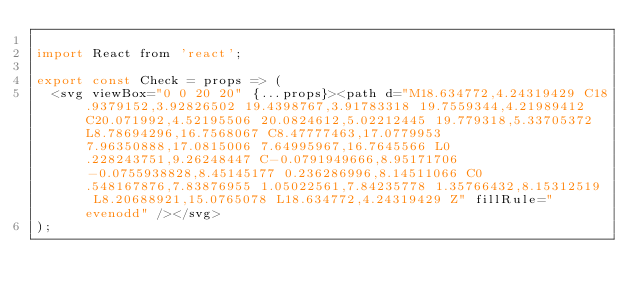<code> <loc_0><loc_0><loc_500><loc_500><_JavaScript_>
import React from 'react';

export const Check = props => (
  <svg viewBox="0 0 20 20" {...props}><path d="M18.634772,4.24319429 C18.9379152,3.92826502 19.4398767,3.91783318 19.7559344,4.21989412 C20.071992,4.52195506 20.0824612,5.02212445 19.779318,5.33705372 L8.78694296,16.7568067 C8.47777463,17.0779953 7.96350888,17.0815006 7.64995967,16.7645566 L0.228243751,9.26248447 C-0.0791949666,8.95171706 -0.0755938828,8.45145177 0.236286996,8.14511066 C0.548167876,7.83876955 1.05022561,7.84235778 1.35766432,8.15312519 L8.20688921,15.0765078 L18.634772,4.24319429 Z" fillRule="evenodd" /></svg>
);
</code> 